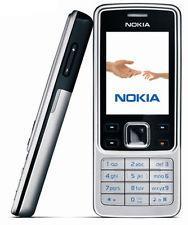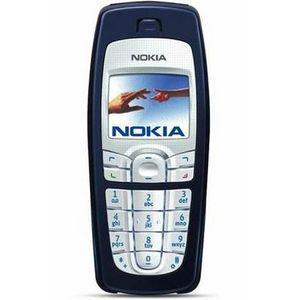The first image is the image on the left, the second image is the image on the right. Assess this claim about the two images: "Both pictures are showing only the front of at least two mobile phones.". Correct or not? Answer yes or no. No. The first image is the image on the left, the second image is the image on the right. Given the left and right images, does the statement "The right image contains a single phone displayed upright, and the left image shows one phone overlapping another one that is not in side-view." hold true? Answer yes or no. No. 